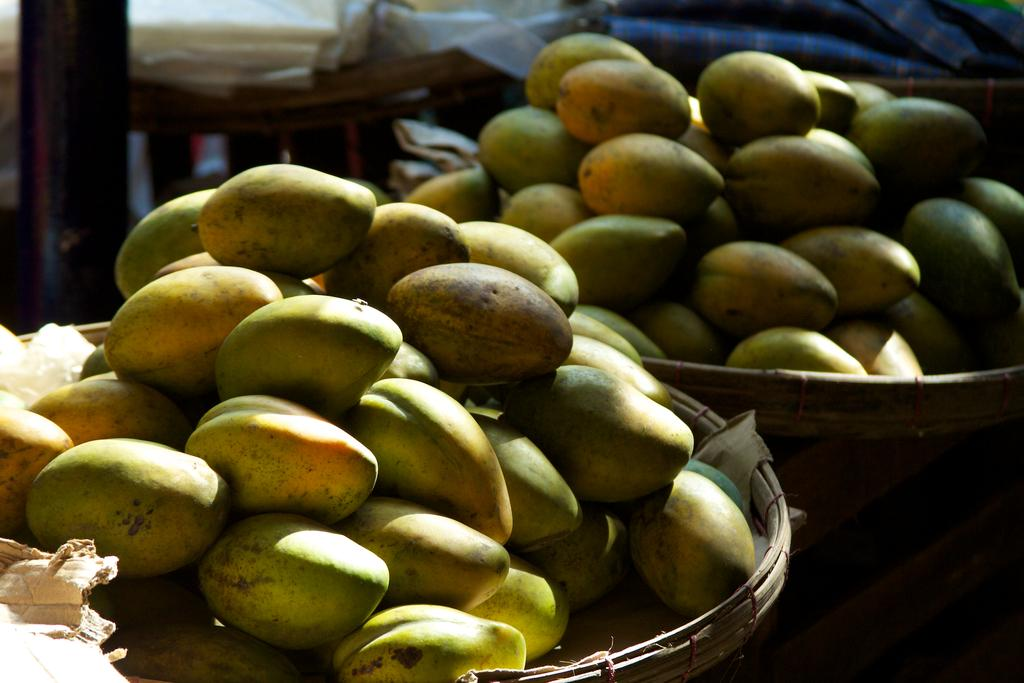What is the main subject of the image? The main subject of the image is two baskets of mangoes. Where are the baskets of mangoes located in the image? The baskets of mangoes are in the center of the image. Can you describe the background of the image? The background area of the image is blurred. What time of day is it in the image, and how does the rice contribute to the scene? The time of day is not mentioned in the image, and there is no rice present in the image. 